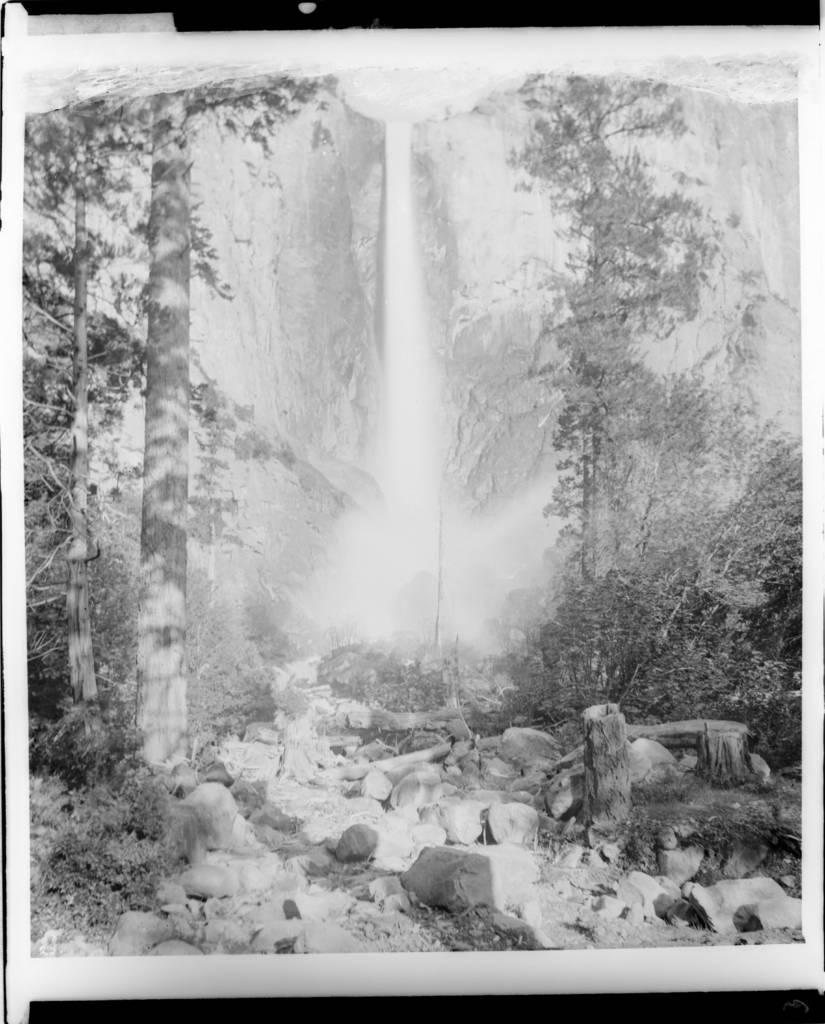What is the main subject of the poster in the image? The poster contains pictures of stones, trees, and waterfalls. Can you describe the different elements depicted on the poster? The poster contains a picture of stones, trees, and waterfalls. What type of natural elements are featured on the poster? The poster features stones, trees, and waterfalls, which are all natural elements. What type of reward can be seen hanging from the trees in the image? There is no reward hanging from the trees in the image; the poster only contains pictures of stones, trees, and waterfalls. 